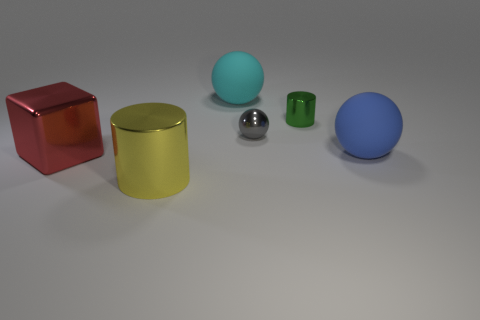What time of day does the lighting in this scene suggest? The lighting in the scene appears to be neutral, suggesting it is either indoor lighting or a cloudy day, as there are no strong shadows or indications of direct sunlight. The soft shadows hint at a diffuse light source, typically used in studio settings. 